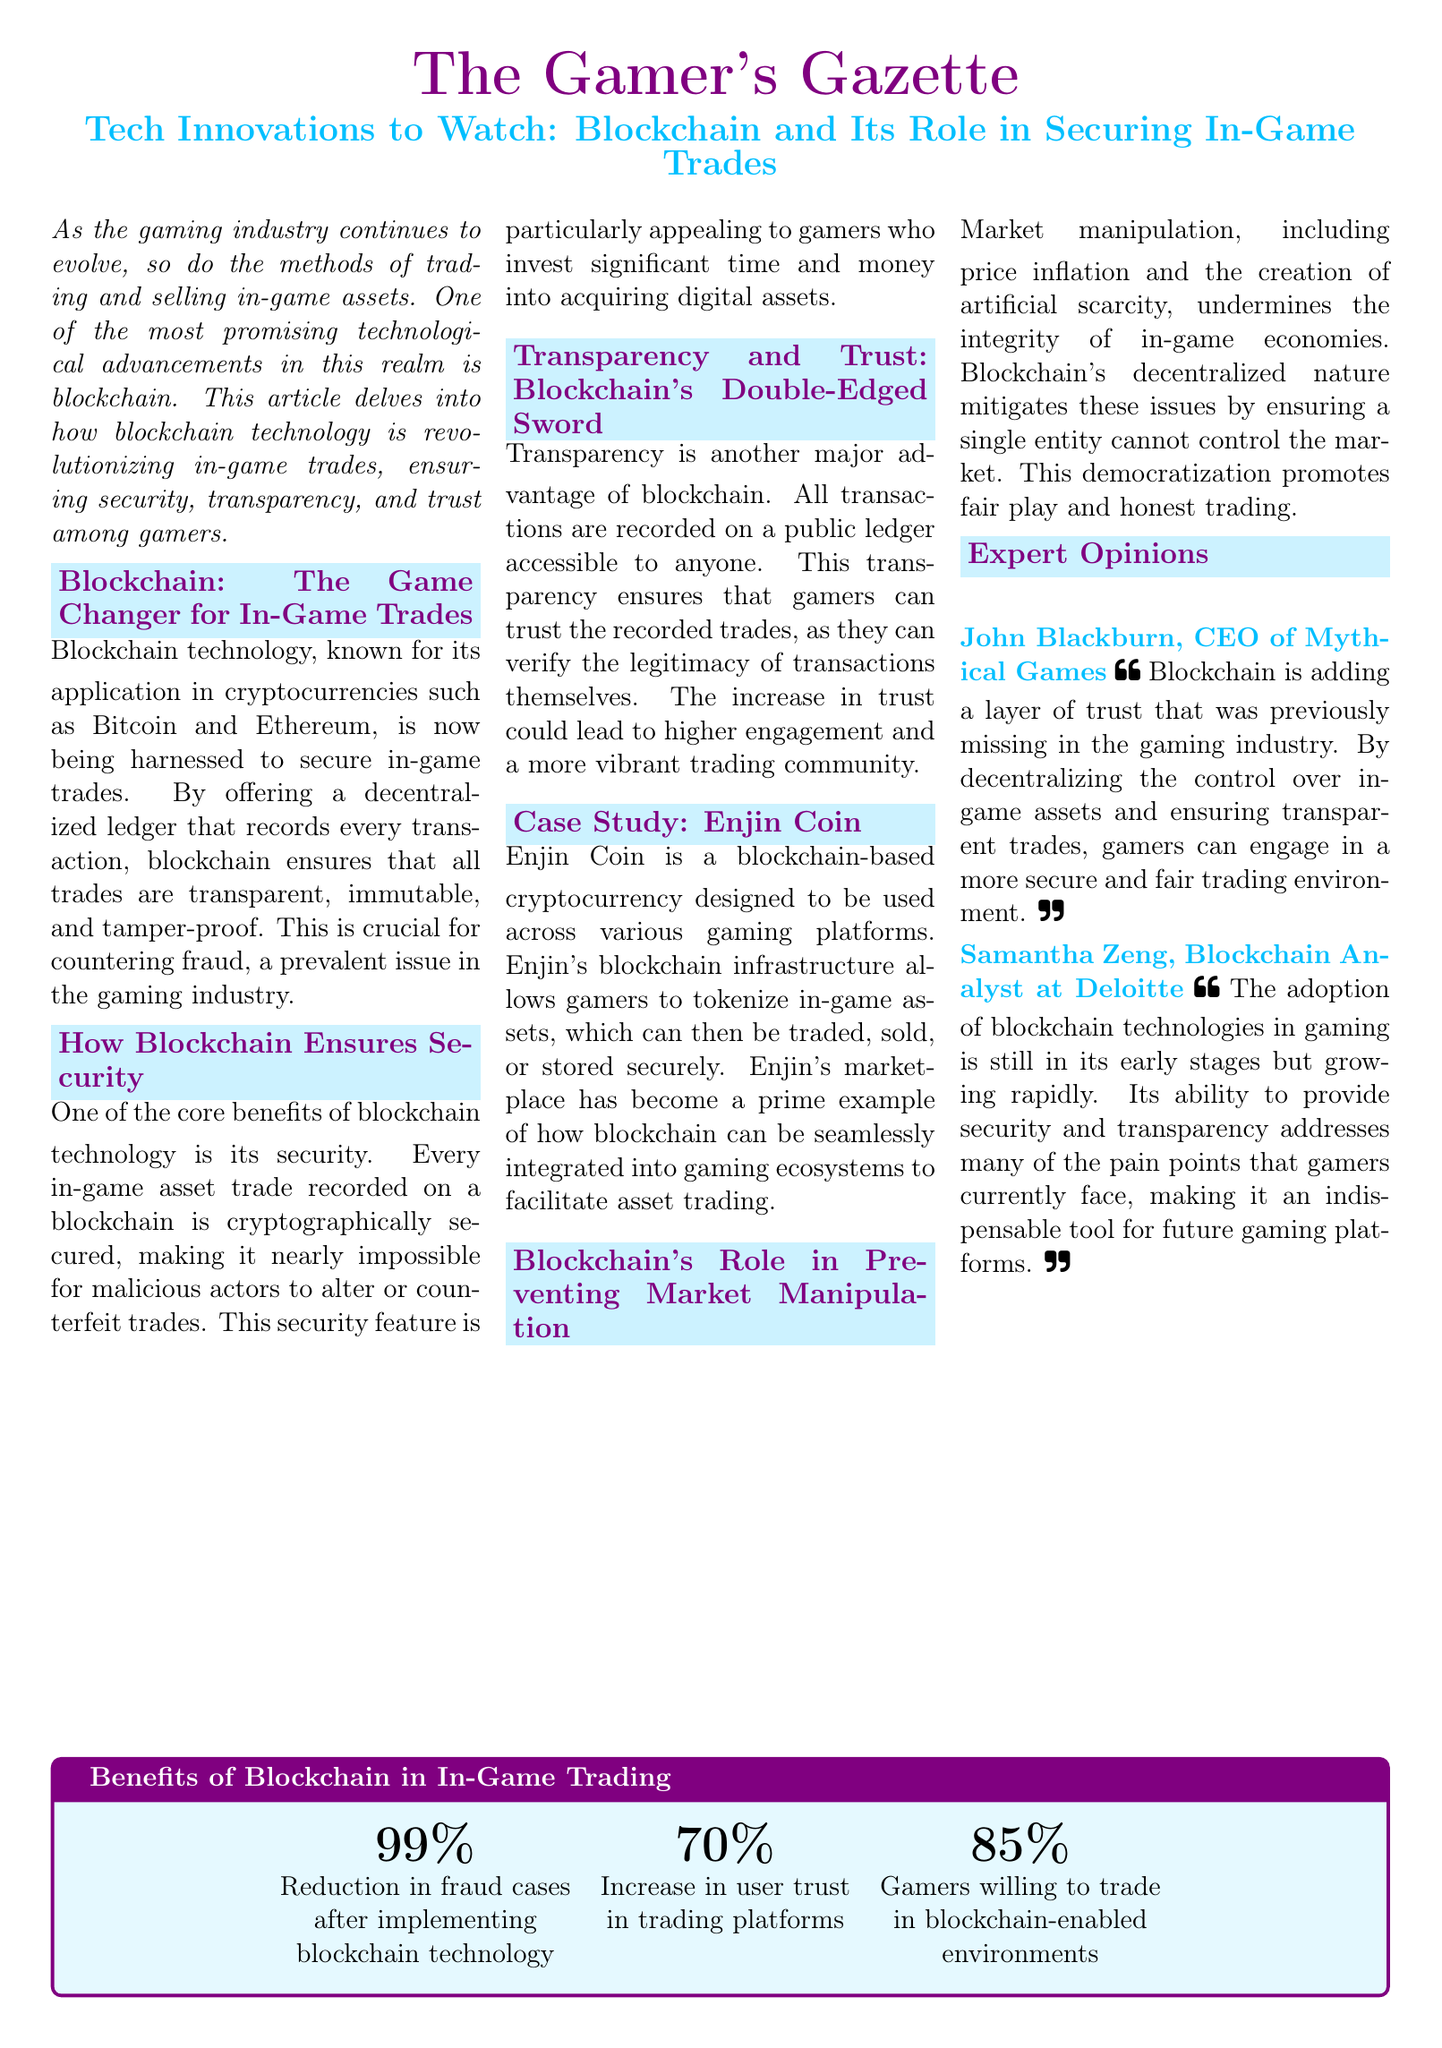What is the title of the article? The title is clearly stated in the document and is "Tech Innovations to Watch: Blockchain and Its Role in Securing In-Game Trades."
Answer: Tech Innovations to Watch: Blockchain and Its Role in Securing In-Game Trades Who is the CEO of Mythical Games quoted in the article? The document provides a quote from John Blackburn, identified as the CEO of Mythical Games.
Answer: John Blackburn What cryptocurrency is mentioned as a case study in the article? The article specifically highlights Enjin Coin as an example of blockchain in gaming.
Answer: Enjin Coin What percentage reduction in fraud cases is stated? The infographic in the document lists a percentage related to the reduction in fraud cases as a key benefit of blockchain technology.
Answer: 99% What benefit of blockchain is indicated by a 70% figure? The document specifies that 70% refers to the increase in user trust in trading platforms after implementing blockchain technology.
Answer: Increase in user trust What does blockchain mitigate regarding market integrity? The document describes that blockchain mitigates issues related to market manipulation, specifically discussing price inflation and artificial scarcity.
Answer: Market manipulation What feature of blockchain makes it nearly impossible to alter trades? A key point made in the document mentions that trades are secured cryptographically to prevent alterations.
Answer: Cryptographically secured How many percentages are listed in the benefits table? The benefits table lists three specific percentages, indicating the various advantages of blockchain in trading.
Answer: Three 